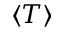Convert formula to latex. <formula><loc_0><loc_0><loc_500><loc_500>\langle T \rangle</formula> 